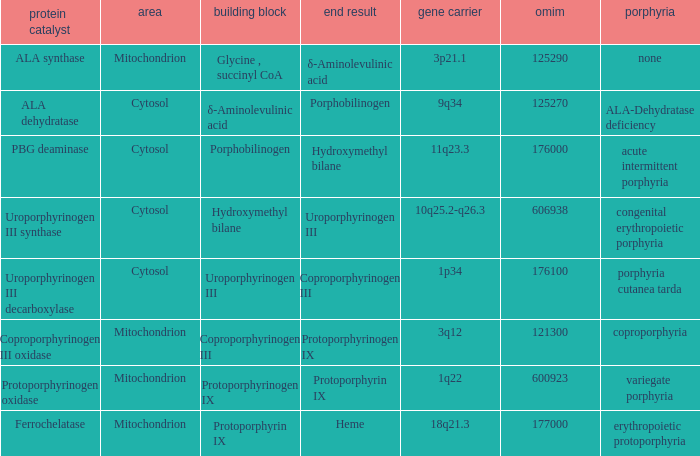What is the location of the enzyme Uroporphyrinogen iii Synthase? Cytosol. 